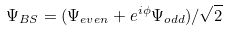Convert formula to latex. <formula><loc_0><loc_0><loc_500><loc_500>\Psi _ { B S } = ( \Psi _ { e v e n } + e ^ { i \phi } \Psi _ { o d d } ) / \sqrt { 2 }</formula> 